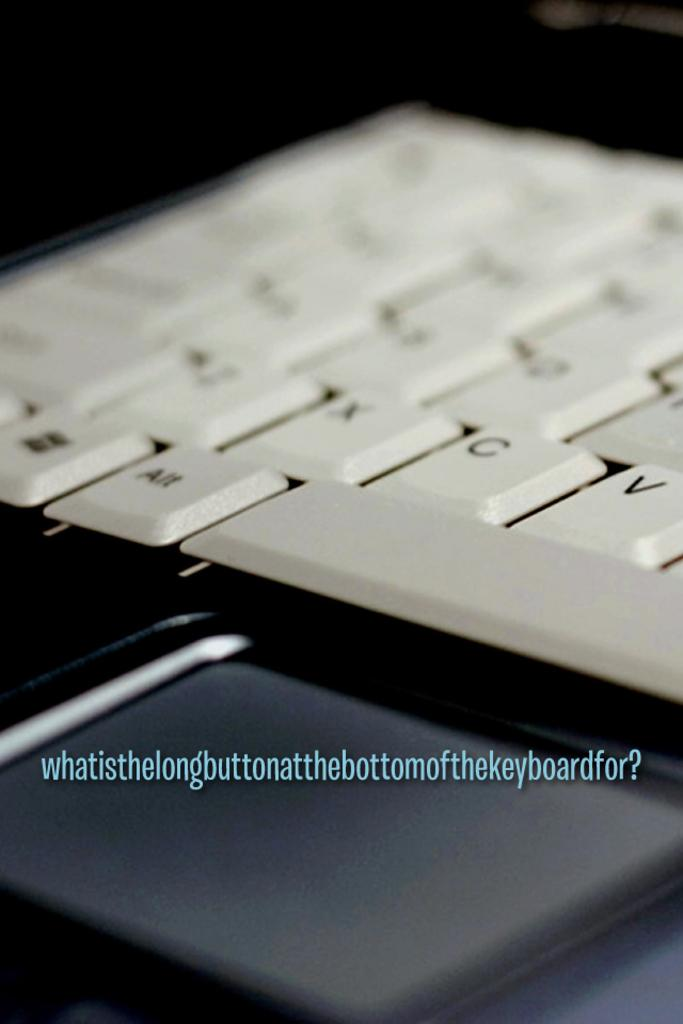What is the main focus of the image? The main focus of the image is a white color keyboard in the center of the image. Can you describe the color of the object in the foreground? There is a black color object in the foreground. Is there any text visible in the image? Yes, text is visible on the image. How close is the view of the image? The image is zoomed in. What type of transport is visible in the image? There is no transport visible in the image; it features a white color keyboard and a black color object in the foreground. Can you tell me how many hydrants are present in the image? There are no hydrants present in the image. 